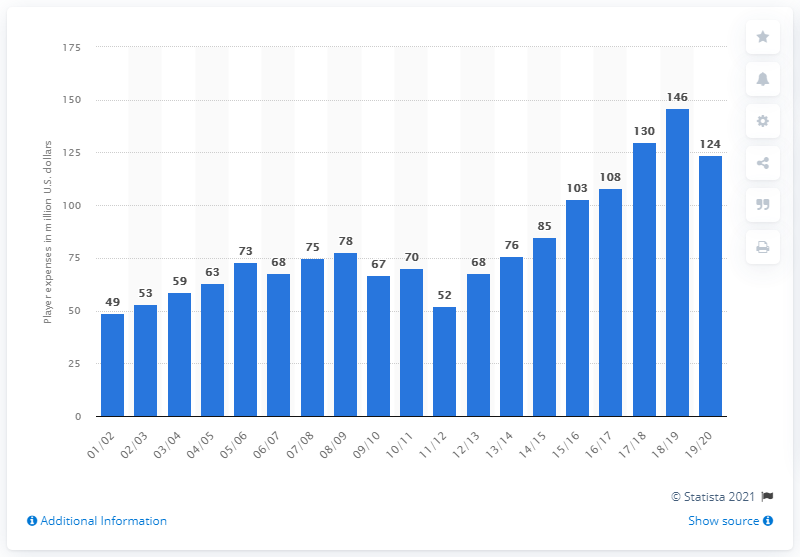Mention a couple of crucial points in this snapshot. The Houston Rockets' salary in the 2019/20 season was 124 million dollars. 